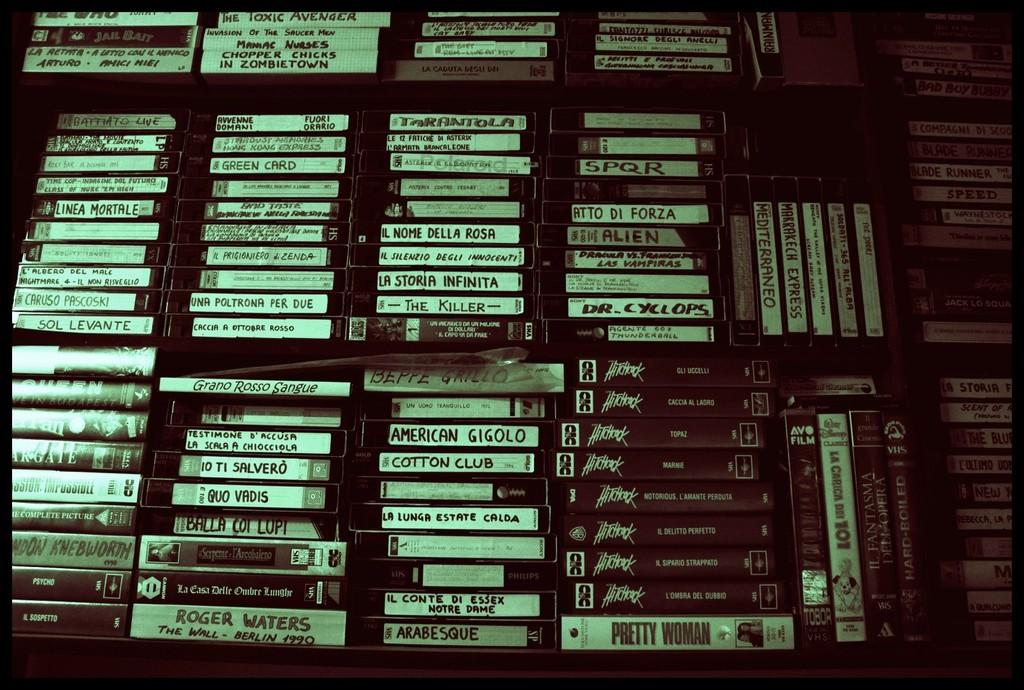What type of women is the bottom tape?
Make the answer very short. Pretty. What tape is on the bottom left?
Offer a very short reply. Roger waters. 